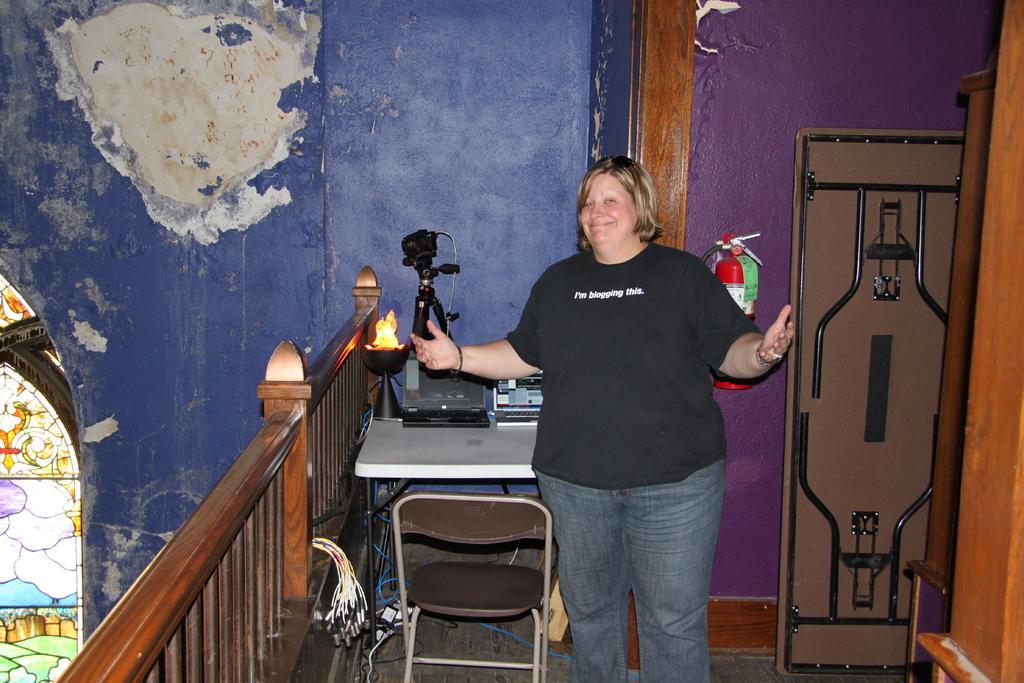How would you summarize this image in a sentence or two? In this picture I can see a woman standing and I can see a table and a chair and looks like a light on the table and I can see fire extinguisher on the wall and a folding table on the right side and looks like a designer glass to the window. 